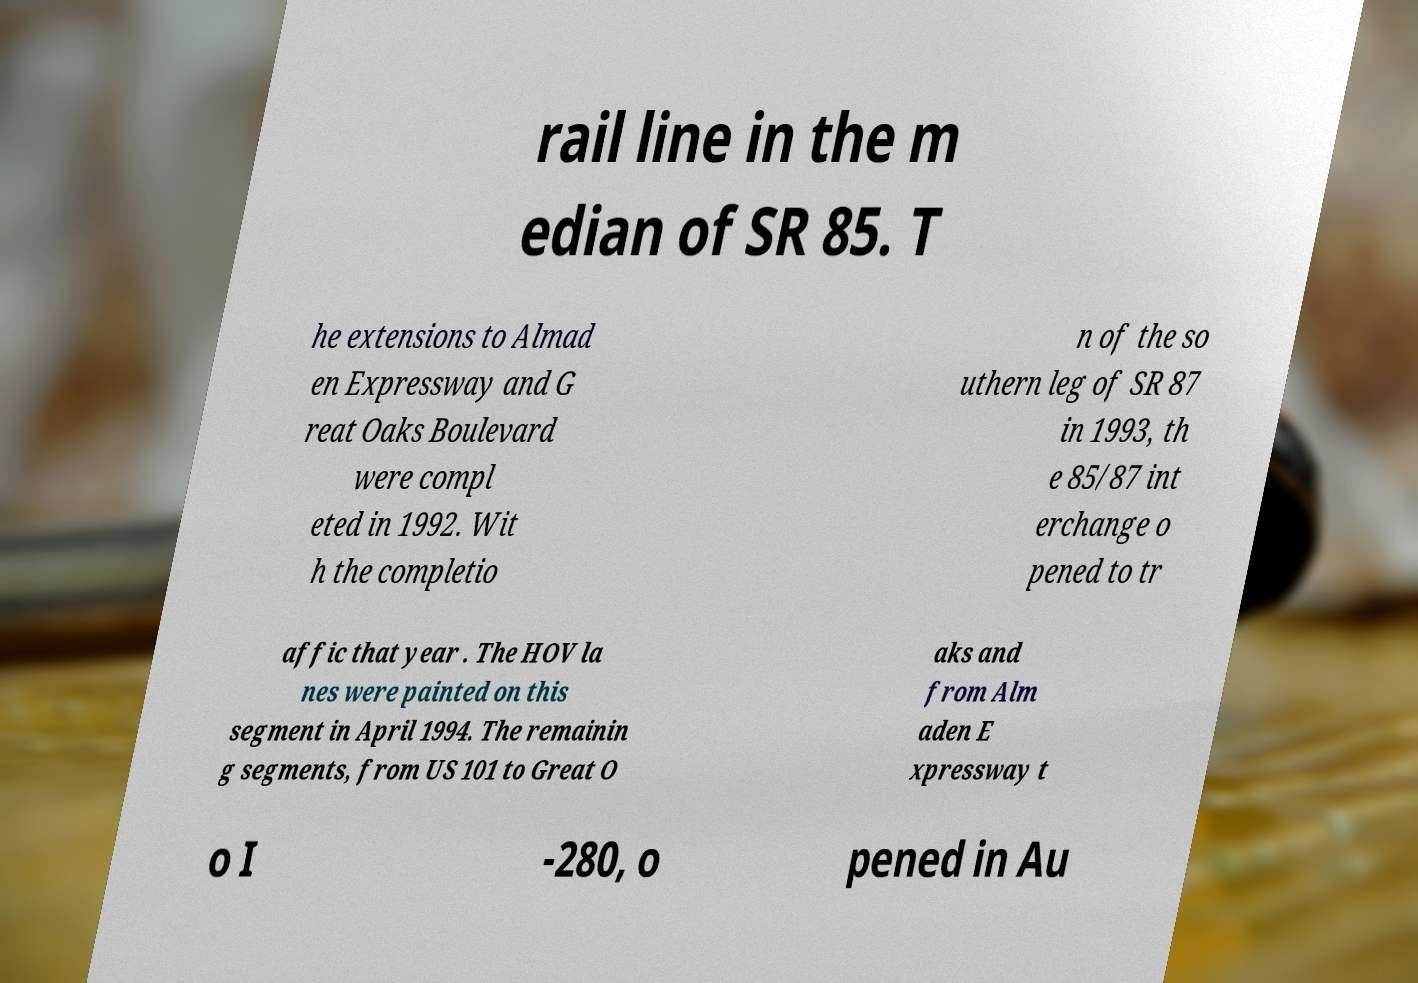Could you assist in decoding the text presented in this image and type it out clearly? rail line in the m edian of SR 85. T he extensions to Almad en Expressway and G reat Oaks Boulevard were compl eted in 1992. Wit h the completio n of the so uthern leg of SR 87 in 1993, th e 85/87 int erchange o pened to tr affic that year . The HOV la nes were painted on this segment in April 1994. The remainin g segments, from US 101 to Great O aks and from Alm aden E xpressway t o I -280, o pened in Au 